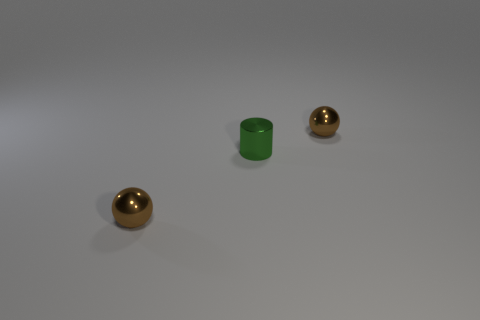There is a shiny thing that is in front of the green metallic thing that is in front of the shiny ball behind the tiny cylinder; what is its color? The color of the shiny thing in front of the green metallic object, which is situated ahead of a shiny ball and behind a tiny cylinder, is gold, not brown. 